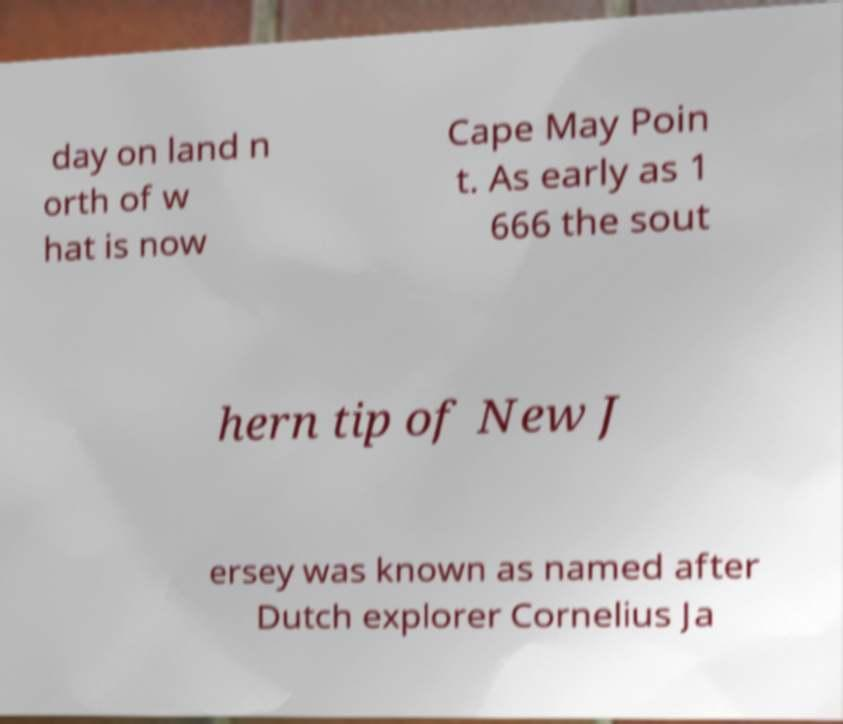Please read and relay the text visible in this image. What does it say? day on land n orth of w hat is now Cape May Poin t. As early as 1 666 the sout hern tip of New J ersey was known as named after Dutch explorer Cornelius Ja 